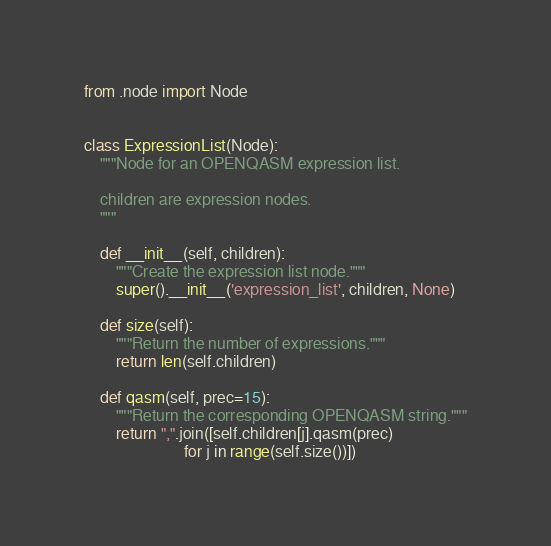Convert code to text. <code><loc_0><loc_0><loc_500><loc_500><_Python_>
from .node import Node


class ExpressionList(Node):
    """Node for an OPENQASM expression list.

    children are expression nodes.
    """

    def __init__(self, children):
        """Create the expression list node."""
        super().__init__('expression_list', children, None)

    def size(self):
        """Return the number of expressions."""
        return len(self.children)

    def qasm(self, prec=15):
        """Return the corresponding OPENQASM string."""
        return ",".join([self.children[j].qasm(prec)
                         for j in range(self.size())])
</code> 